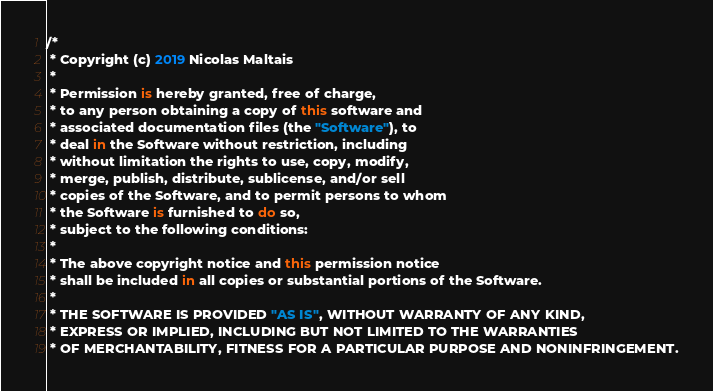Convert code to text. <code><loc_0><loc_0><loc_500><loc_500><_Kotlin_>/*
 * Copyright (c) 2019 Nicolas Maltais
 *
 * Permission is hereby granted, free of charge,
 * to any person obtaining a copy of this software and
 * associated documentation files (the "Software"), to
 * deal in the Software without restriction, including
 * without limitation the rights to use, copy, modify,
 * merge, publish, distribute, sublicense, and/or sell
 * copies of the Software, and to permit persons to whom
 * the Software is furnished to do so,
 * subject to the following conditions:
 *
 * The above copyright notice and this permission notice
 * shall be included in all copies or substantial portions of the Software.
 *
 * THE SOFTWARE IS PROVIDED "AS IS", WITHOUT WARRANTY OF ANY KIND,
 * EXPRESS OR IMPLIED, INCLUDING BUT NOT LIMITED TO THE WARRANTIES
 * OF MERCHANTABILITY, FITNESS FOR A PARTICULAR PURPOSE AND NONINFRINGEMENT.</code> 